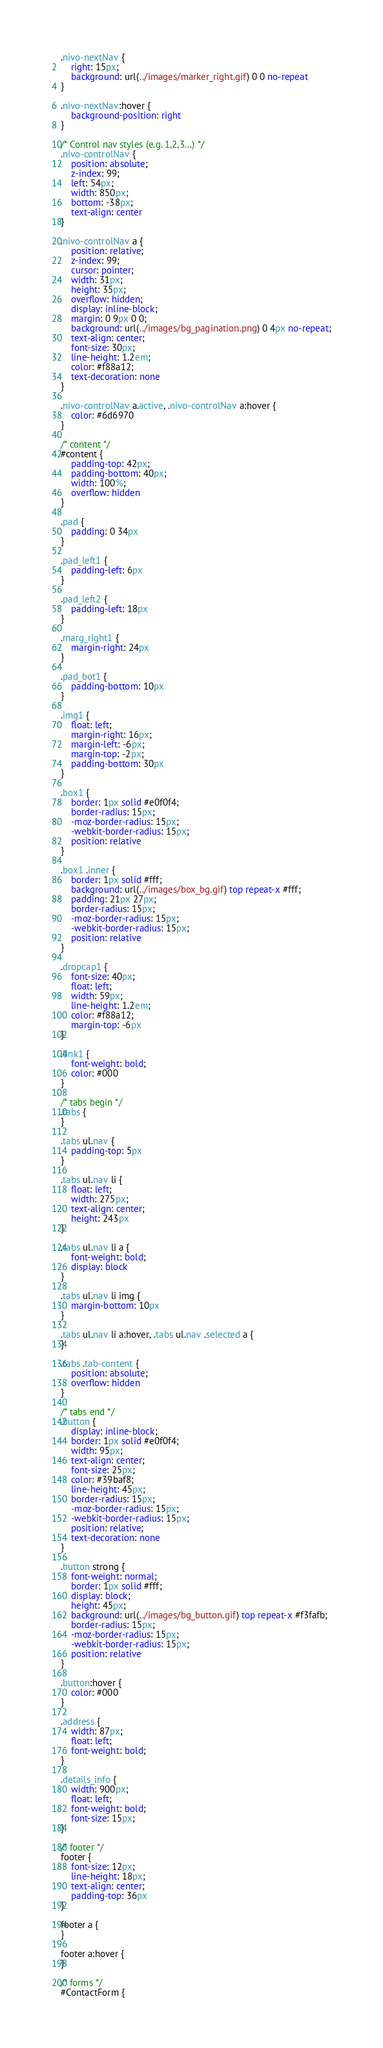<code> <loc_0><loc_0><loc_500><loc_500><_CSS_>.nivo-nextNav {
    right: 15px;
    background: url(../images/marker_right.gif) 0 0 no-repeat
}

.nivo-nextNav:hover {
    background-position: right
}

/* Control nav styles (e.g. 1,2,3...) */
.nivo-controlNav {
    position: absolute;
    z-index: 99;
    left: 54px;
    width: 850px;
    bottom: -38px;
    text-align: center
}

.nivo-controlNav a {
    position: relative;
    z-index: 99;
    cursor: pointer;
    width: 31px;
    height: 35px;
    overflow: hidden;
    display: inline-block;
    margin: 0 9px 0 0;
    background: url(../images/bg_pagination.png) 0 4px no-repeat;
    text-align: center;
    font-size: 30px;
    line-height: 1.2em;
    color: #f88a12;
    text-decoration: none
}

.nivo-controlNav a.active, .nivo-controlNav a:hover {
    color: #6d6970
}

/* content */
#content {
    padding-top: 42px;
    padding-bottom: 40px;
    width: 100%;
    overflow: hidden
}

.pad {
    padding: 0 34px
}

.pad_left1 {
    padding-left: 6px
}

.pad_left2 {
    padding-left: 18px
}

.marg_right1 {
    margin-right: 24px
}

.pad_bot1 {
    padding-bottom: 10px
}

.img1 {
    float: left;
    margin-right: 16px;
    margin-left: -6px;
    margin-top: -2px;
    padding-bottom: 30px
}

.box1 {
    border: 1px solid #e0f0f4;
    border-radius: 15px;
    -moz-border-radius: 15px;
    -webkit-border-radius: 15px;
    position: relative
}

.box1 .inner {
    border: 1px solid #fff;
    background: url(../images/box_bg.gif) top repeat-x #fff;
    padding: 21px 27px;
    border-radius: 15px;
    -moz-border-radius: 15px;
    -webkit-border-radius: 15px;
    position: relative
}

.dropcap1 {
    font-size: 40px;
    float: left;
    width: 59px;
    line-height: 1.2em;
    color: #f88a12;
    margin-top: -6px
}

.link1 {
    font-weight: bold;
    color: #000
}

/* tabs begin */
.tabs {
}

.tabs ul.nav {
    padding-top: 5px
}

.tabs ul.nav li {
    float: left;
    width: 275px;
    text-align: center;
    height: 243px
}

.tabs ul.nav li a {
    font-weight: bold;
    display: block
}

.tabs ul.nav li img {
    margin-bottom: 10px
}

.tabs ul.nav li a:hover, .tabs ul.nav .selected a {
}

.tabs .tab-content {
    position: absolute;
    overflow: hidden
}

/* tabs end */
.button {
    display: inline-block;
    border: 1px solid #e0f0f4;
    width: 95px;
    text-align: center;
    font-size: 25px;
    color: #39baf8;
    line-height: 45px;
    border-radius: 15px;
    -moz-border-radius: 15px;
    -webkit-border-radius: 15px;
    position: relative;
    text-decoration: none
}

.button strong {
    font-weight: normal;
    border: 1px solid #fff;
    display: block;
    height: 45px;
    background: url(../images/bg_button.gif) top repeat-x #f3fafb;
    border-radius: 15px;
    -moz-border-radius: 15px;
    -webkit-border-radius: 15px;
    position: relative
}

.button:hover {
    color: #000
}

.address {
    width: 87px;
    float: left;
    font-weight: bold;
}

.details_info {
    width: 900px;
    float: left;
    font-weight: bold;
    font-size: 15px;
}

/* footer */
footer {
    font-size: 12px;
    line-height: 18px;
    text-align: center;
    padding-top: 36px
}

footer a {
}

footer a:hover {
}

/* forms */
#ContactForm {</code> 